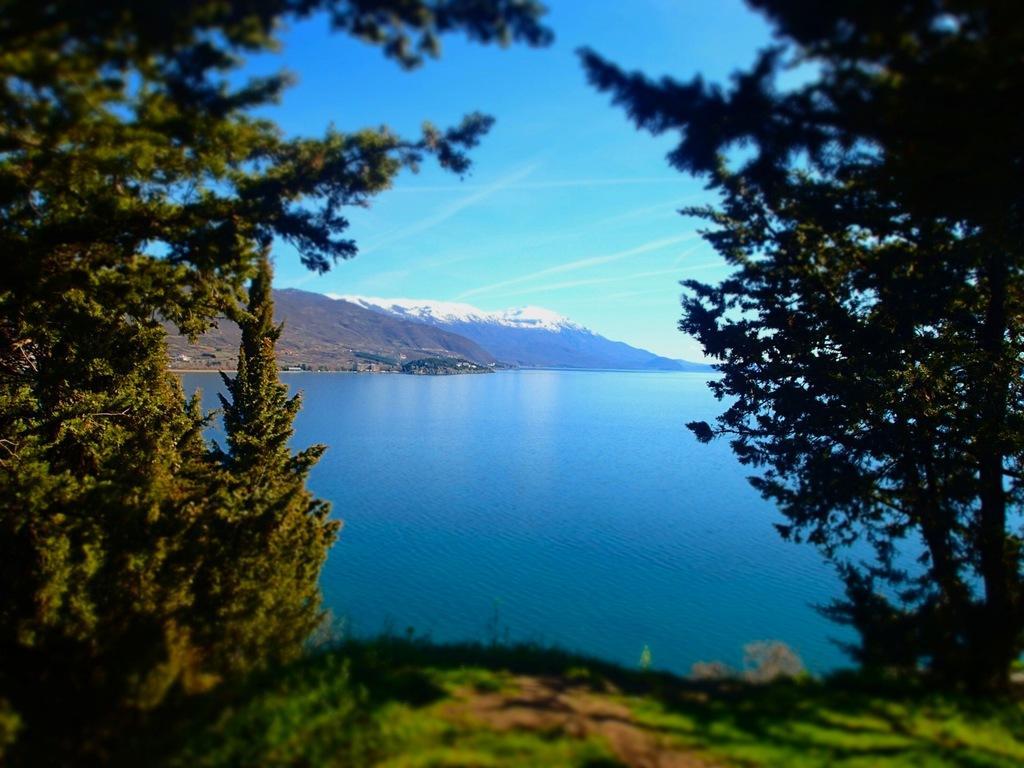Can you describe this image briefly? This image is clicked outside. There are trees on the left side and right side. There is water in the middle. There are mountains in the middle. There is sky at the top. 